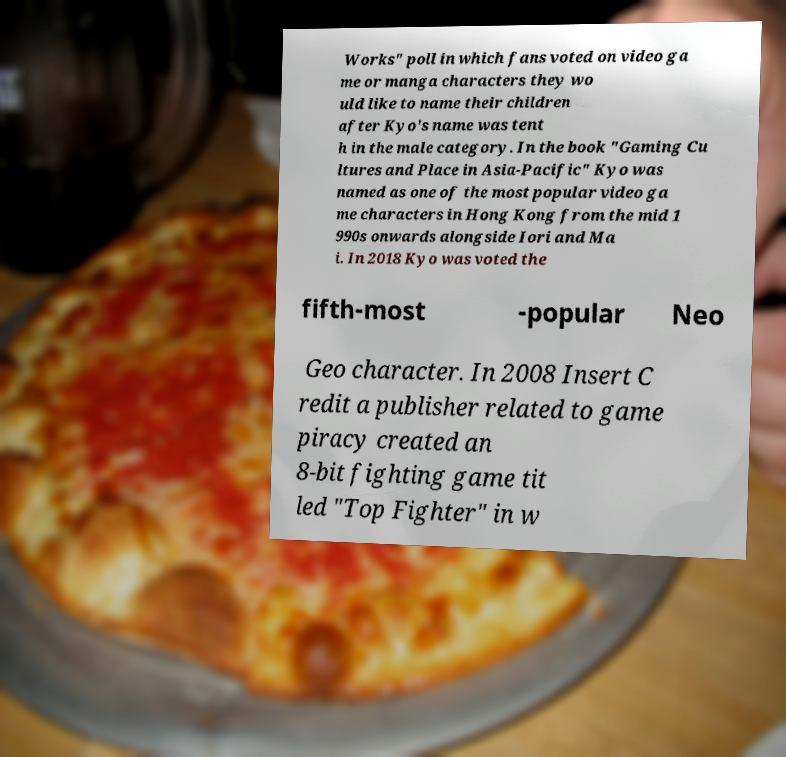Can you accurately transcribe the text from the provided image for me? Works" poll in which fans voted on video ga me or manga characters they wo uld like to name their children after Kyo's name was tent h in the male category. In the book "Gaming Cu ltures and Place in Asia-Pacific" Kyo was named as one of the most popular video ga me characters in Hong Kong from the mid 1 990s onwards alongside Iori and Ma i. In 2018 Kyo was voted the fifth-most -popular Neo Geo character. In 2008 Insert C redit a publisher related to game piracy created an 8-bit fighting game tit led "Top Fighter" in w 